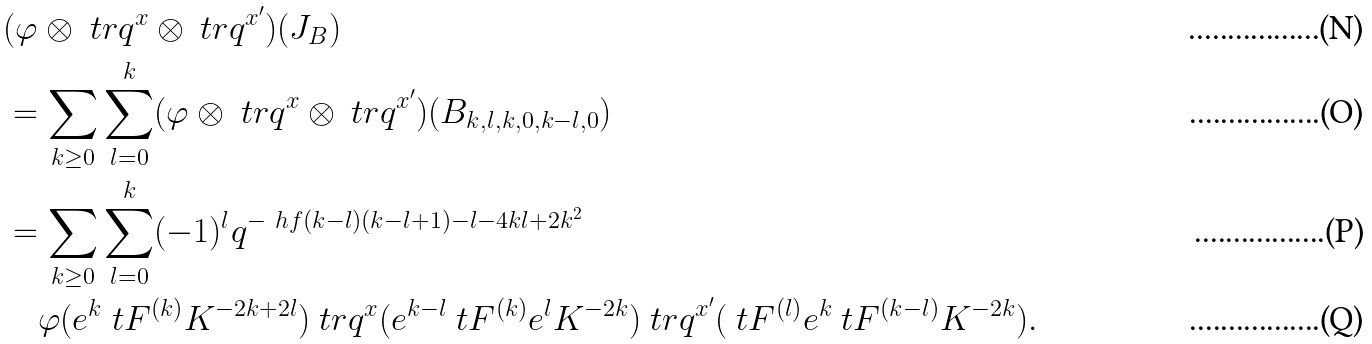Convert formula to latex. <formula><loc_0><loc_0><loc_500><loc_500>& ( \varphi \otimes \ t r q ^ { x } \otimes \ t r q ^ { x ^ { \prime } } ) ( J _ { B } ) \\ & = \sum _ { k \geq 0 } \sum _ { l = 0 } ^ { k } ( \varphi \otimes \ t r q ^ { x } \otimes \ t r q ^ { x ^ { \prime } } ) ( B _ { k , l , k , 0 , k - l , 0 } ) \\ & = \sum _ { k \geq 0 } \sum _ { l = 0 } ^ { k } ( - 1 ) ^ { l } q ^ { - \ h f ( k - l ) ( k - l + 1 ) - l - 4 k l + 2 k ^ { 2 } } \\ & \quad \varphi ( e ^ { k } \ t F ^ { ( k ) } K ^ { - 2 k + 2 l } ) \ t r q ^ { x } ( e ^ { k - l } \ t F ^ { ( k ) } e ^ { l } K ^ { - 2 k } ) \ t r q ^ { x ^ { \prime } } ( \ t F ^ { ( l ) } e ^ { k } \ t F ^ { ( k - l ) } K ^ { - 2 k } ) .</formula> 